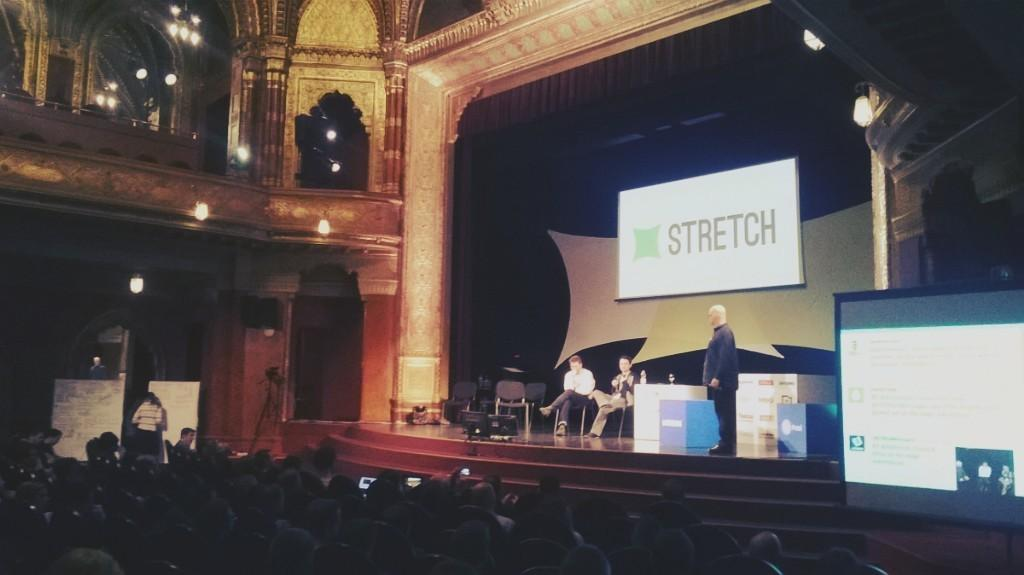<image>
Relay a brief, clear account of the picture shown. A stage with people on it and a screen with STRETCH above them are shown with an audience watching. 